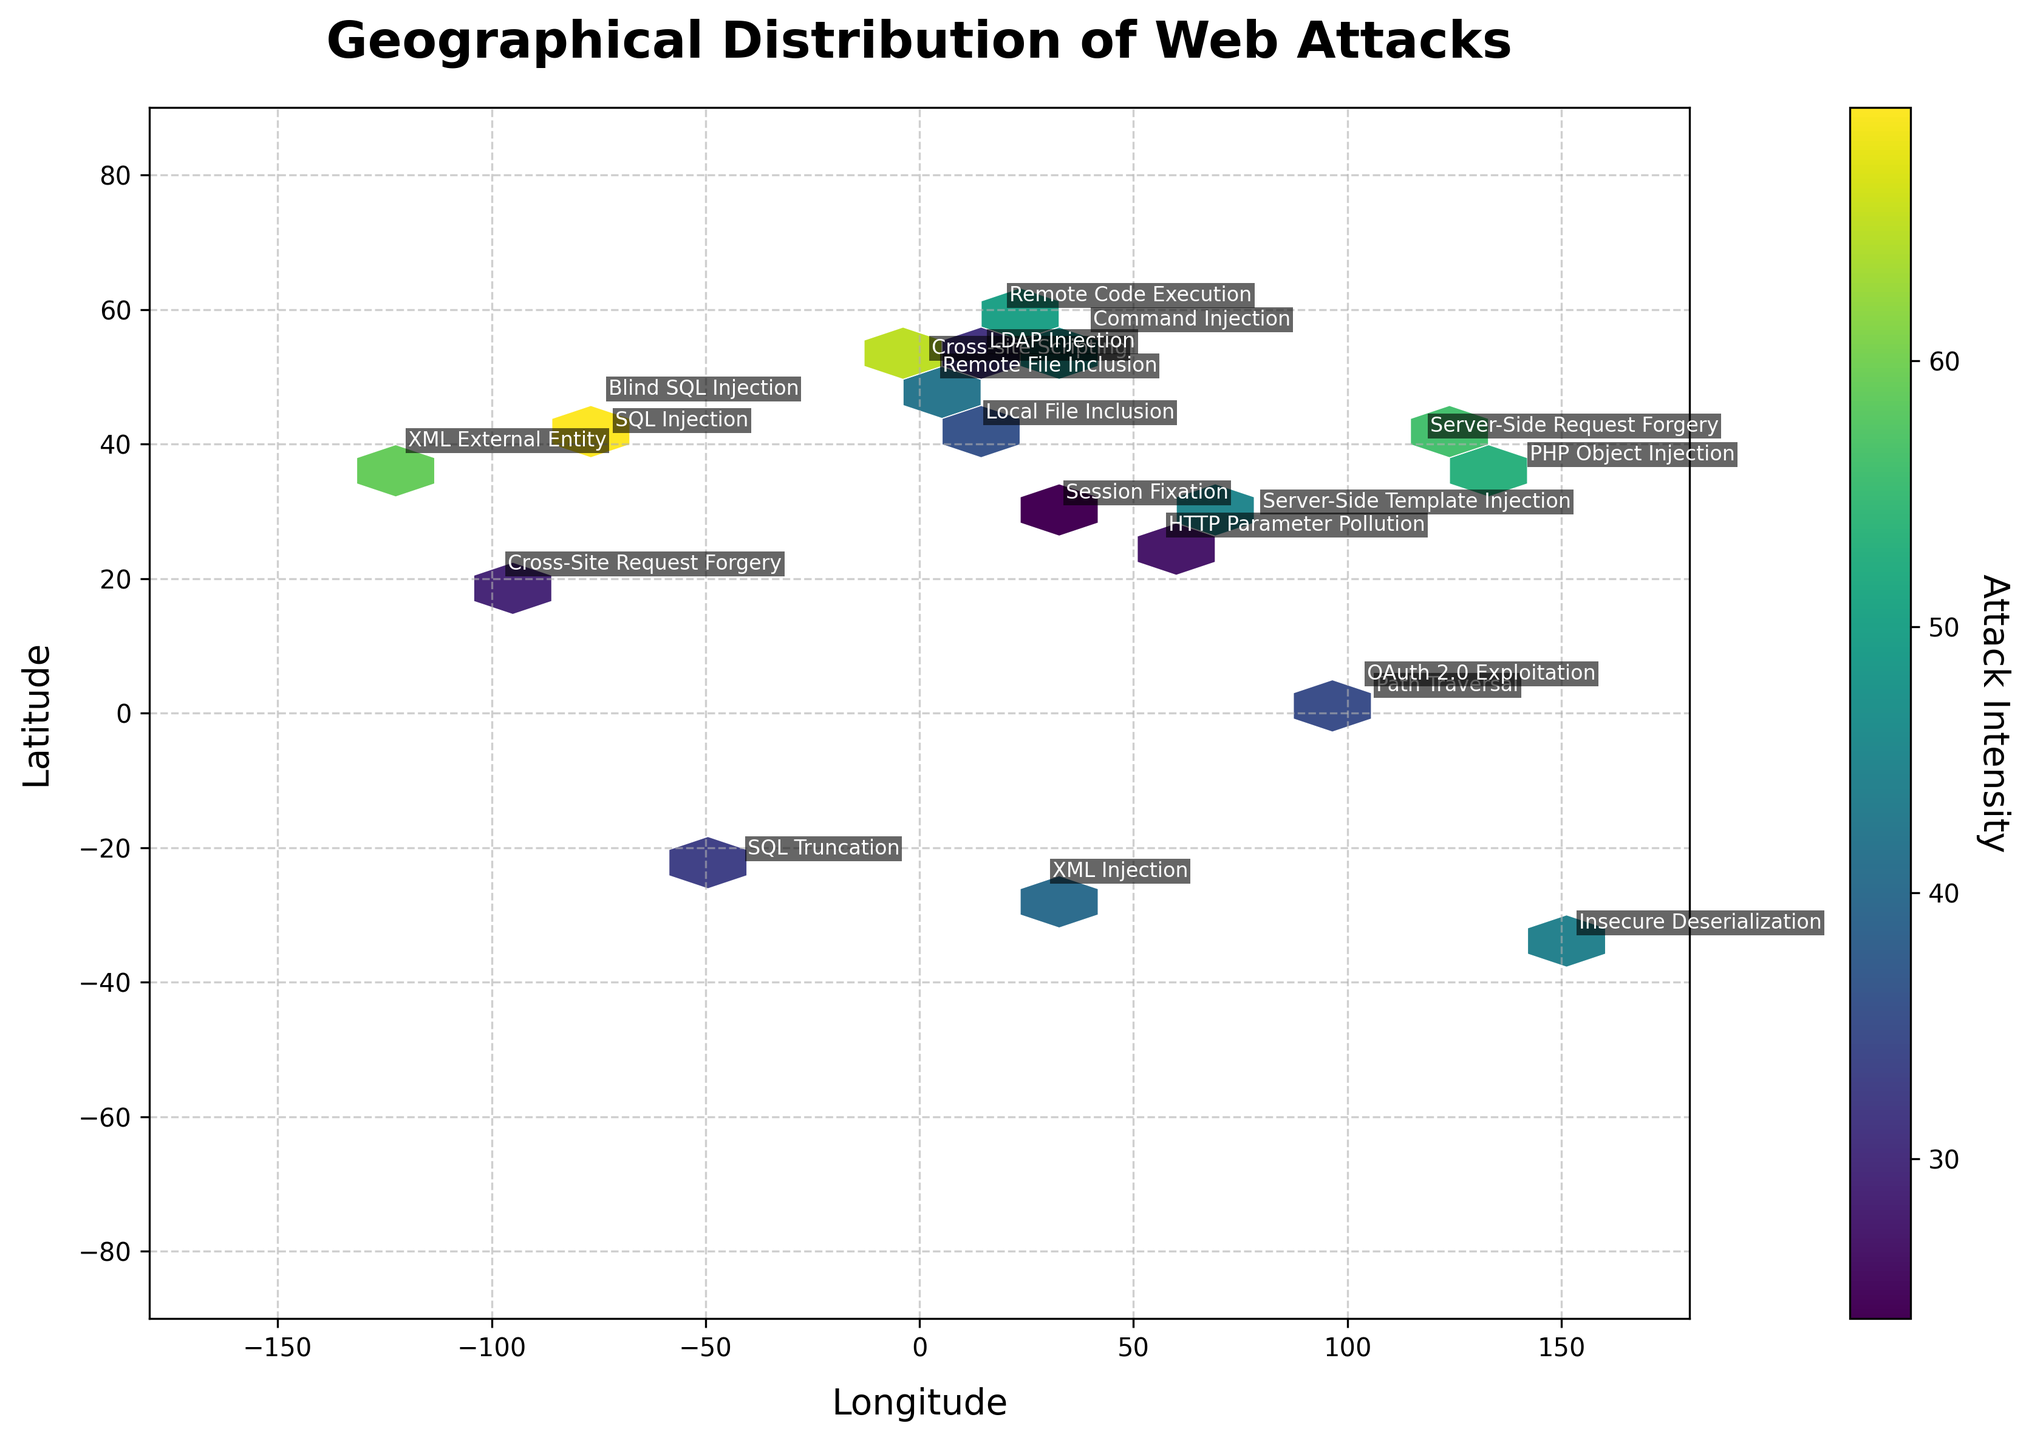What is the title of the plot? The title of the plot is indicated at the top of the figure in a larger and bolder font. In this case, it reads ‘Geographical Distribution of Web Attacks’.
Answer: Geographical Distribution of Web Attacks Where is the highest attack intensity located? By visually inspecting the plot, the highest hexbin color (indicating the highest intensity) is most pronounced around New York.
Answer: New York Which longitude range is covered in the plot? The x-axis runs horizontally and represents the longitude range, which extends from -180 to 180 degrees. This covers the global longitudinal span from the western hemisphere to the eastern hemisphere.
Answer: -180 to 180 degrees What attack type is located at the coordinates (41.9028, 12.4964)? By locating the corresponding coordinates on the plot and reading the annotated text, the attack type is ‘Local File Inclusion’.
Answer: Local File Inclusion How many types of attacks are represented in the plot? Each annotated label on the plot corresponds to a unique attack type. Counting these unique labels results in 20 distinct attack types.
Answer: 20 Which city shows the second highest intensity for web attacks? Visually comparing the hexbin colors, the second highest intensity seems to be in London when compared to other cities.
Answer: London What is the attack intensity in Tokyo? By locating Tokyo (latitude 35.6762, longitude 139.6503) on the plot, the annotated attack intensity can be identified as 53.
Answer: 53 What is the range of attack intensities shown in the color bar? The color bar to the side of the plot displays the range of intensities from the minimum to the maximum observed values. In this case, it ranges from 24 to 78.
Answer: 24 to 78 How many attack types have an intensity greater than 50? By examining the plot and identifying the labels with intensities greater than 50, there are 6 attack types: SQL Injection (78), Cross-site Scripting (65), Blind SQL Injection (61), XML External Entity (59), Server-Side Request Forgery (56), and PHP Object Injection (53).
Answer: 6 Which cities have an attack intensity less than 35? By inspecting the plot for cities with an intensity less than 35, the cities are Cairo (Session Fixation, 24), Dubai (HTTP Parameter Pollution, 27), and Mexico City (Cross-Site Request Forgery, 29).
Answer: Cairo, Dubai, Mexico City 